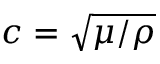<formula> <loc_0><loc_0><loc_500><loc_500>c = \sqrt { \mu / \rho }</formula> 